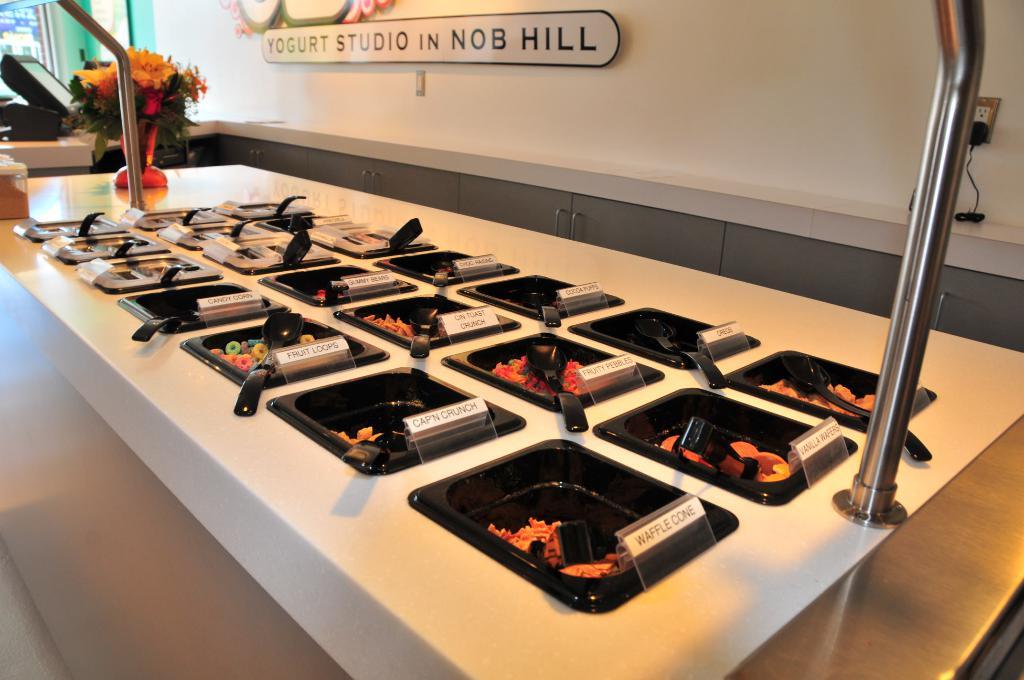What town is this studio in?
Keep it short and to the point. Nob hill. 